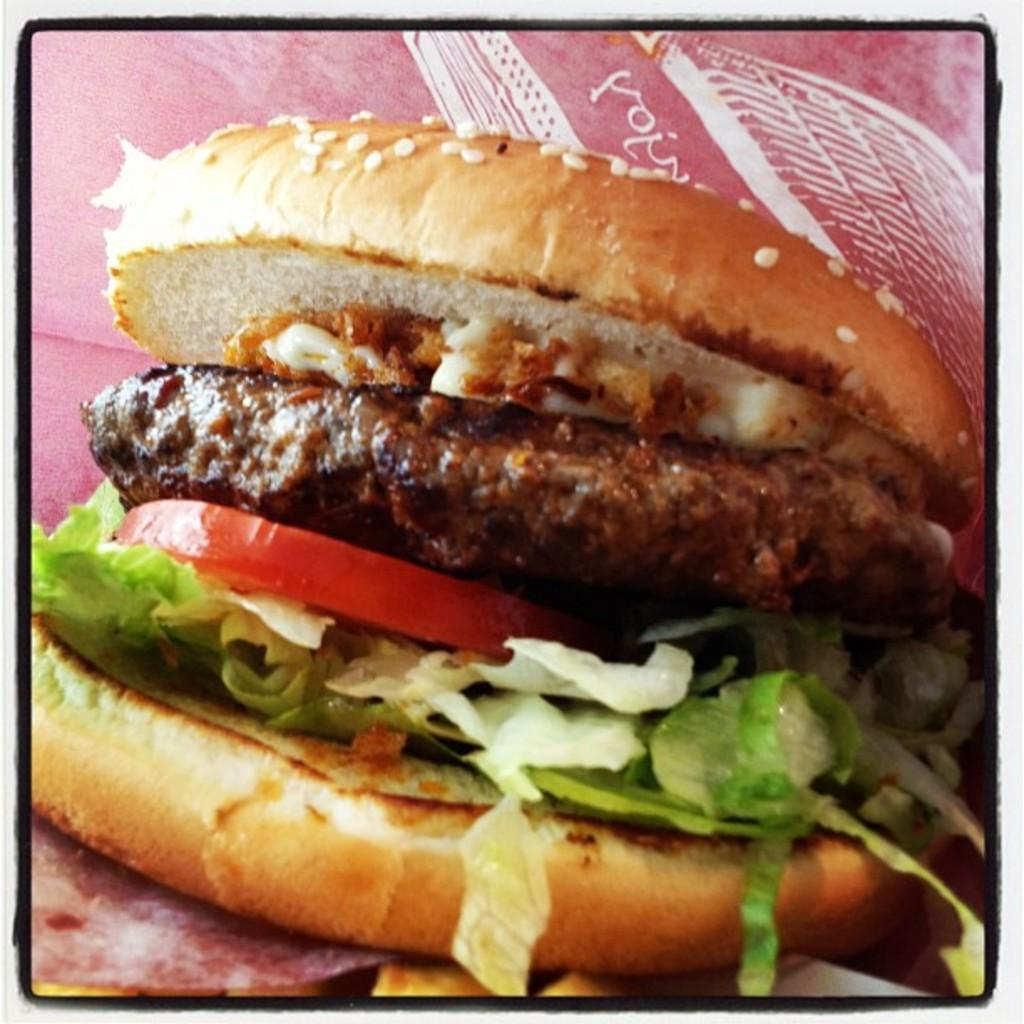What types of items can be seen in the image? There are food items in the image. What type of leather is being used to make the food items in the image? There is no leather present in the image, as it features food items. 